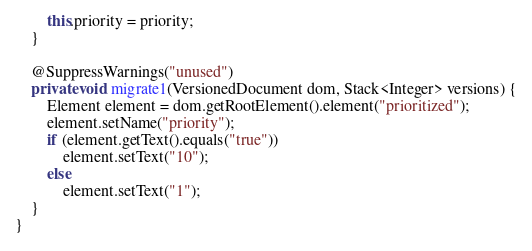<code> <loc_0><loc_0><loc_500><loc_500><_Java_>		this.priority = priority;
	}
	
	@SuppressWarnings("unused")
	private void migrate1(VersionedDocument dom, Stack<Integer> versions) {
		Element element = dom.getRootElement().element("prioritized");
		element.setName("priority");
		if (element.getText().equals("true"))
			element.setText("10");
		else
			element.setText("1");
	}
}
</code> 